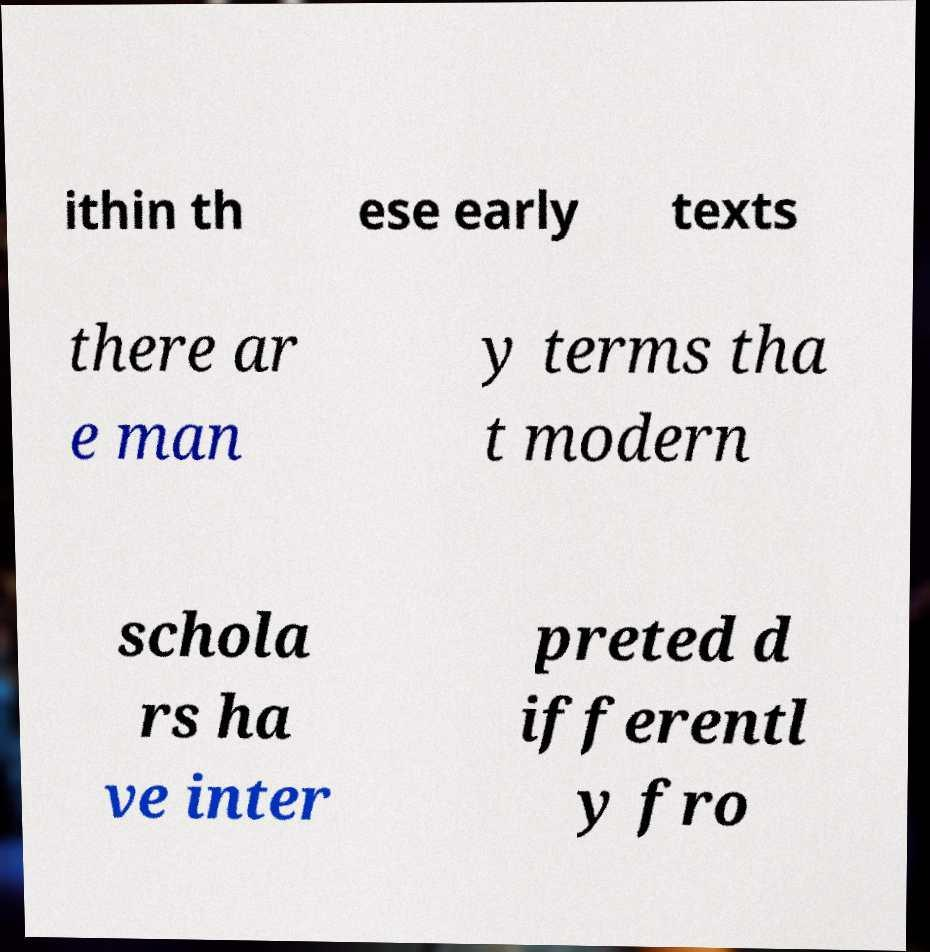There's text embedded in this image that I need extracted. Can you transcribe it verbatim? ithin th ese early texts there ar e man y terms tha t modern schola rs ha ve inter preted d ifferentl y fro 